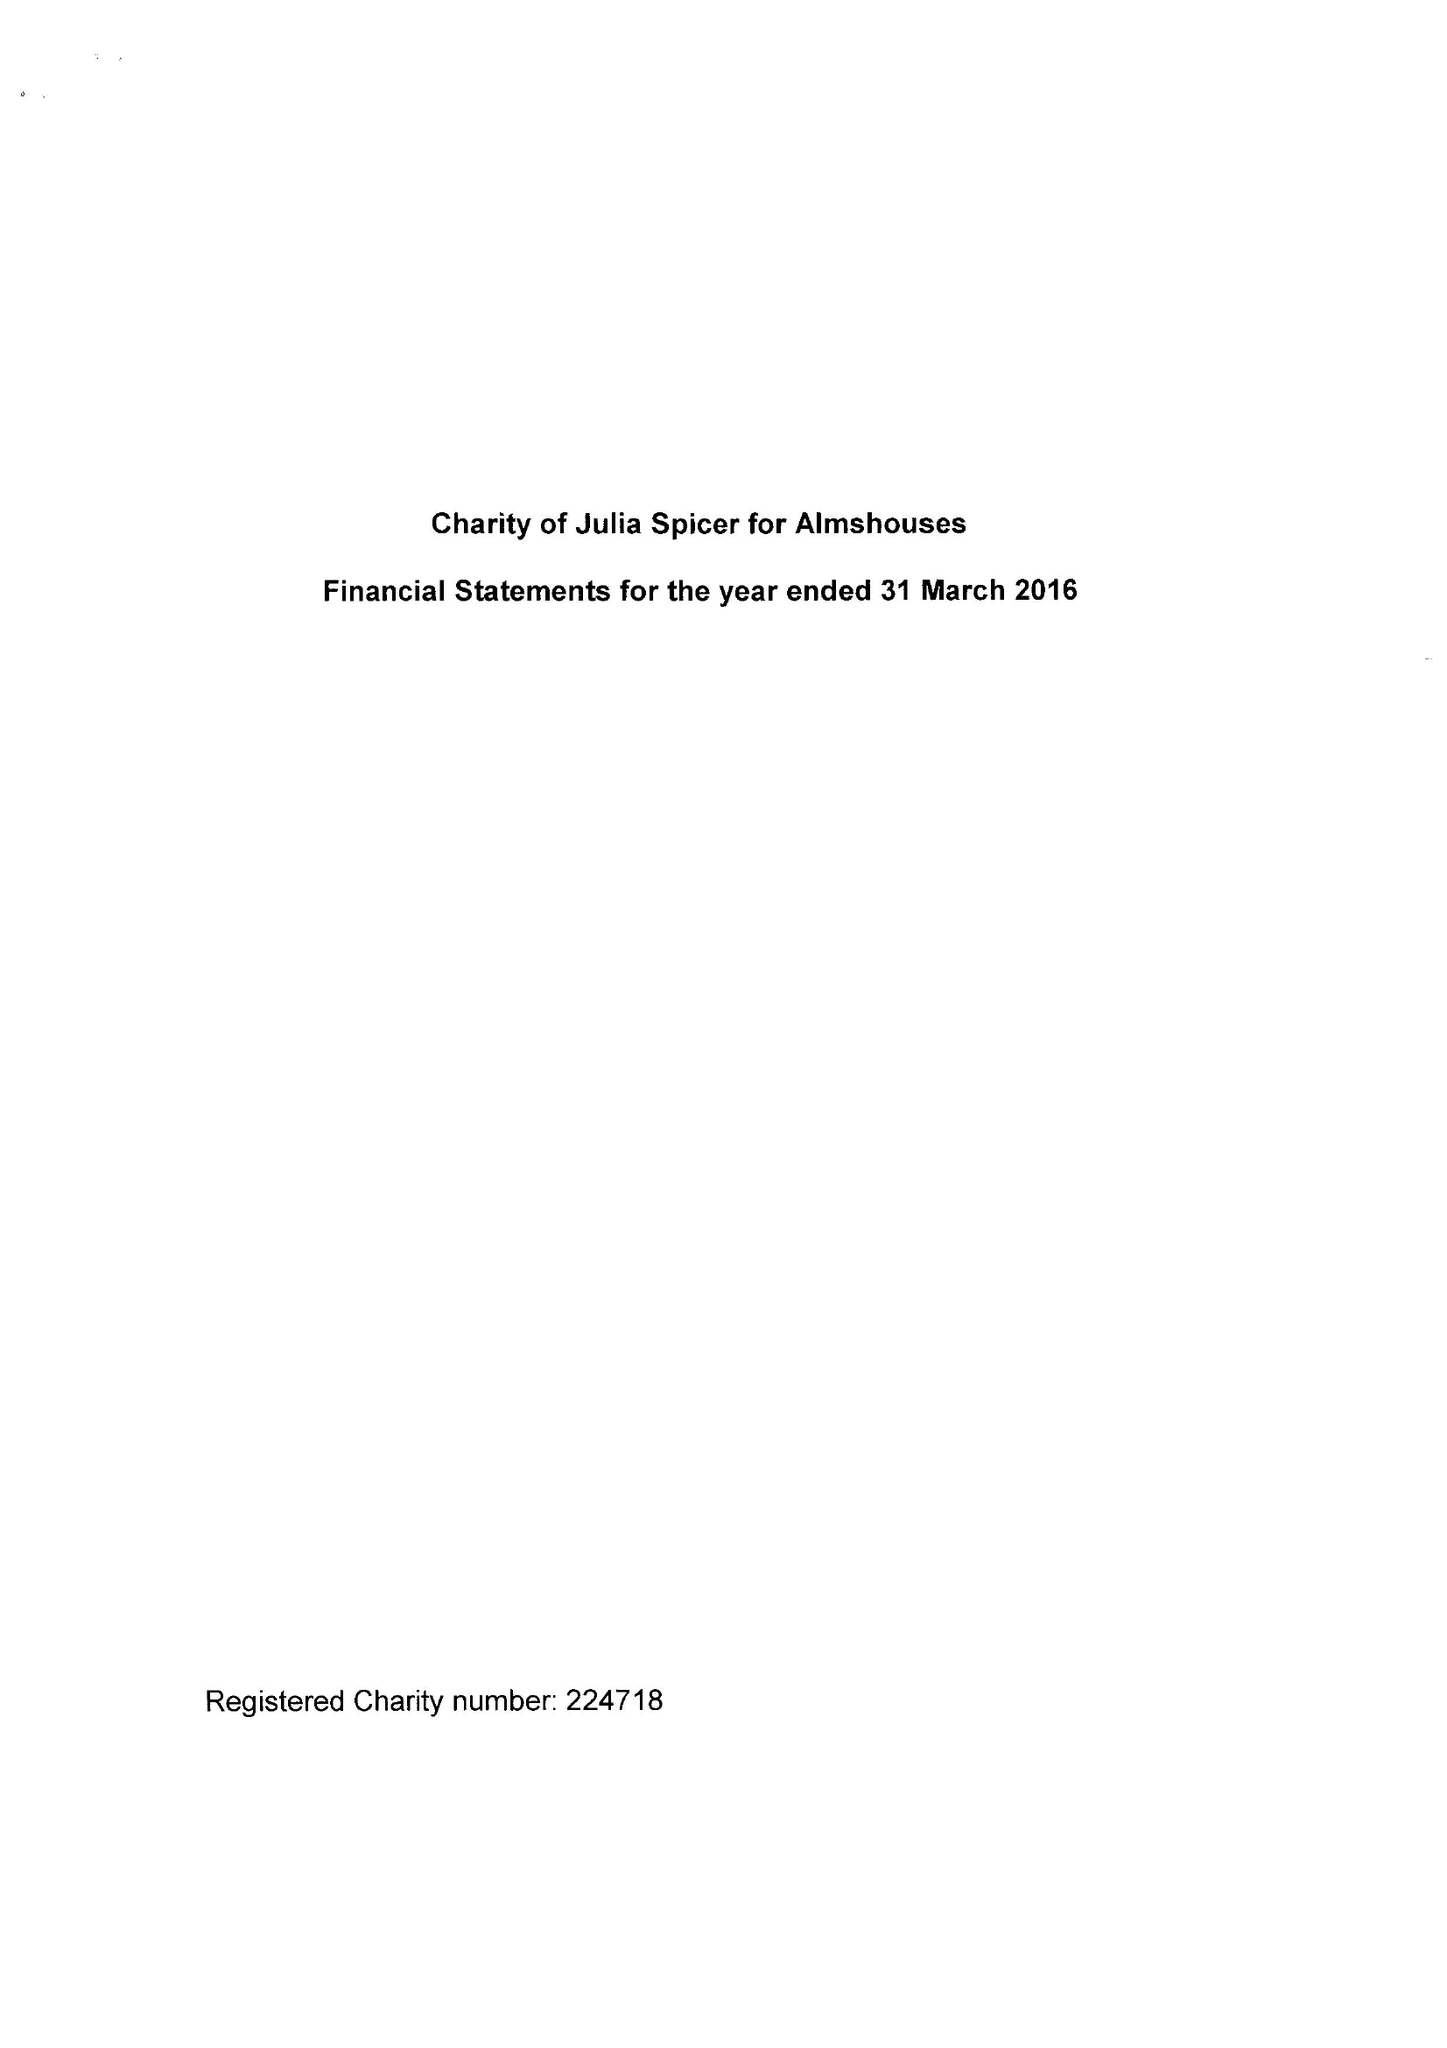What is the value for the address__street_line?
Answer the question using a single word or phrase. 125 HIGH STREET 